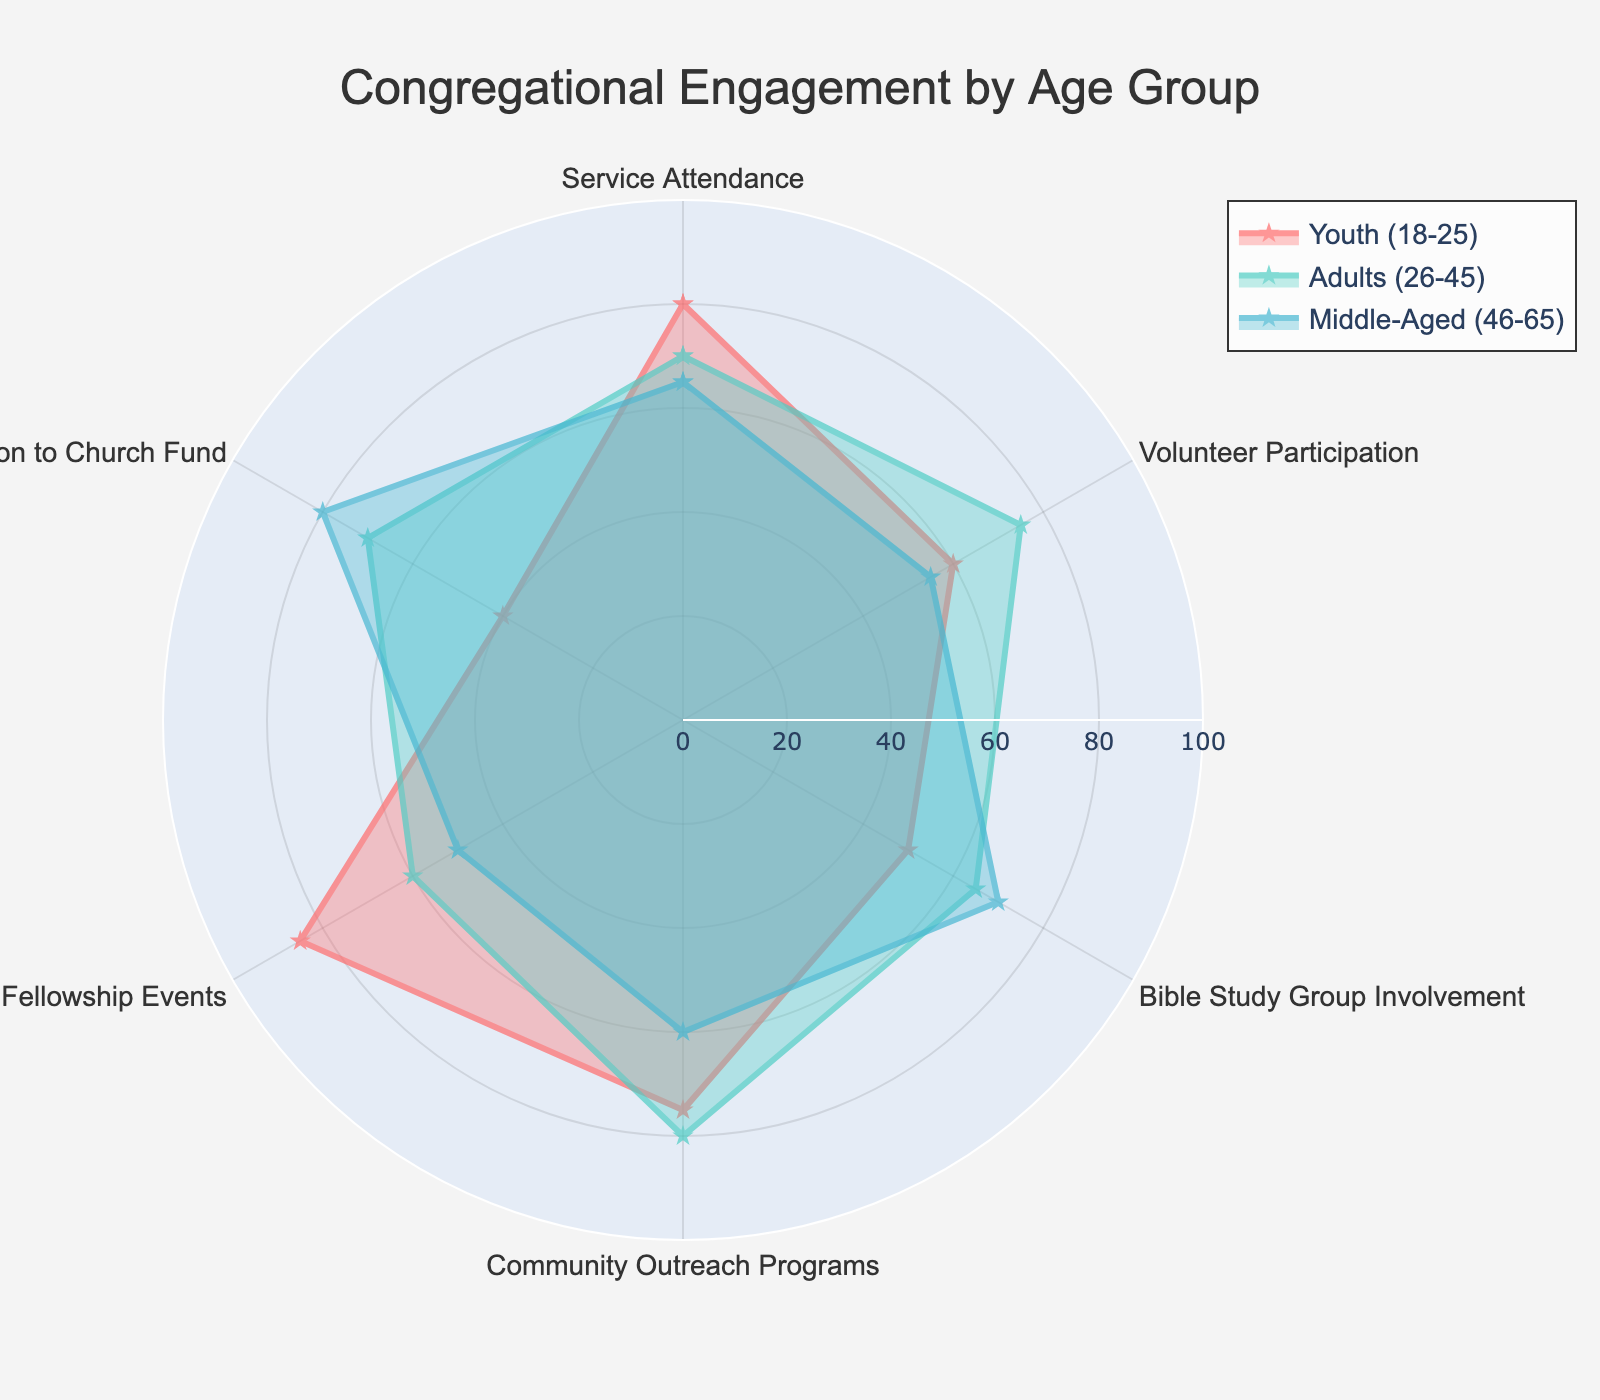Which age group has the highest engagement in Service Attendance? By observing the data points along the Service Attendance axis, the Youth (18-25) group shows the highest value at 80.
Answer: Youth (18-25) What is the average engagement for Middle-Aged (46-65) in all metrics? Summing the engagements for Middle-Aged (46-65) across all activities: 65 + 55 + 70 + 60 + 50 + 80 = 380. The average is 380/6 = 63.33.
Answer: 63.33 Which metric shows the greatest disparity between the highest and lowest scoring age groups? Analyzing each metric:
- Service Attendance: 80 (Youth) - 65 (Middle-Aged) = 15
- Volunteer Participation: 75 (Adults) - 55 (Middle-Aged) = 20
- Bible Study Group Involvement: 70 (Middle-Aged) - 50 (Youth) = 20
- Community Outreach Programs: 80 (Adults) - 60 (Middle-Aged) = 20
- Social Fellowship Events: 85 (Youth) - 50 (Middle-Aged) = 35
- Contribution to Church Fund: 80 (Middle-Aged) - 40 (Youth) = 40
Hence, Contribution to Church Fund shows the greatest disparity (40).
Answer: Contribution to Church Fund Which age group is least engaged in Social Fellowship Events? By observing the data points along the Social Fellowship Events axis, the Middle-Aged (46-65) group shows the lowest value at 50.
Answer: Middle-Aged (46-65) How much higher is the Community Outreach Programs score for Adults (26-45) compared to Youth (18-25)? The Adults (26-45) score 80, and the Youth (18-25) score 75 for Community Outreach Programs. The difference is 80 - 75 = 5.
Answer: 5 Which activity shows the highest participation from any age group? By inspecting the outermost data points in the radar chart, Social Fellowship Events for Youth (18-25) has the highest value at 85.
Answer: Social Fellowship Events Among the Middle-Aged (46-65) group, which engagement metric shows the lowest value? By analyzing the Middle-Aged (46-65) data points, the lowest value is 50 for Social Fellowship Events.
Answer: Social Fellowship Events Which age group has the most balanced engagement across all activities? Analyzing the spread of the values for each group: Youth (18-25) ranges from 40 to 85, Adults (26-45) ranges from 60 to 80, and Middle-Aged (46-65) ranges from 50 to 80. Adults (26-45) have the smallest range (20), hence most balanced.
Answer: Adults (26-45) 